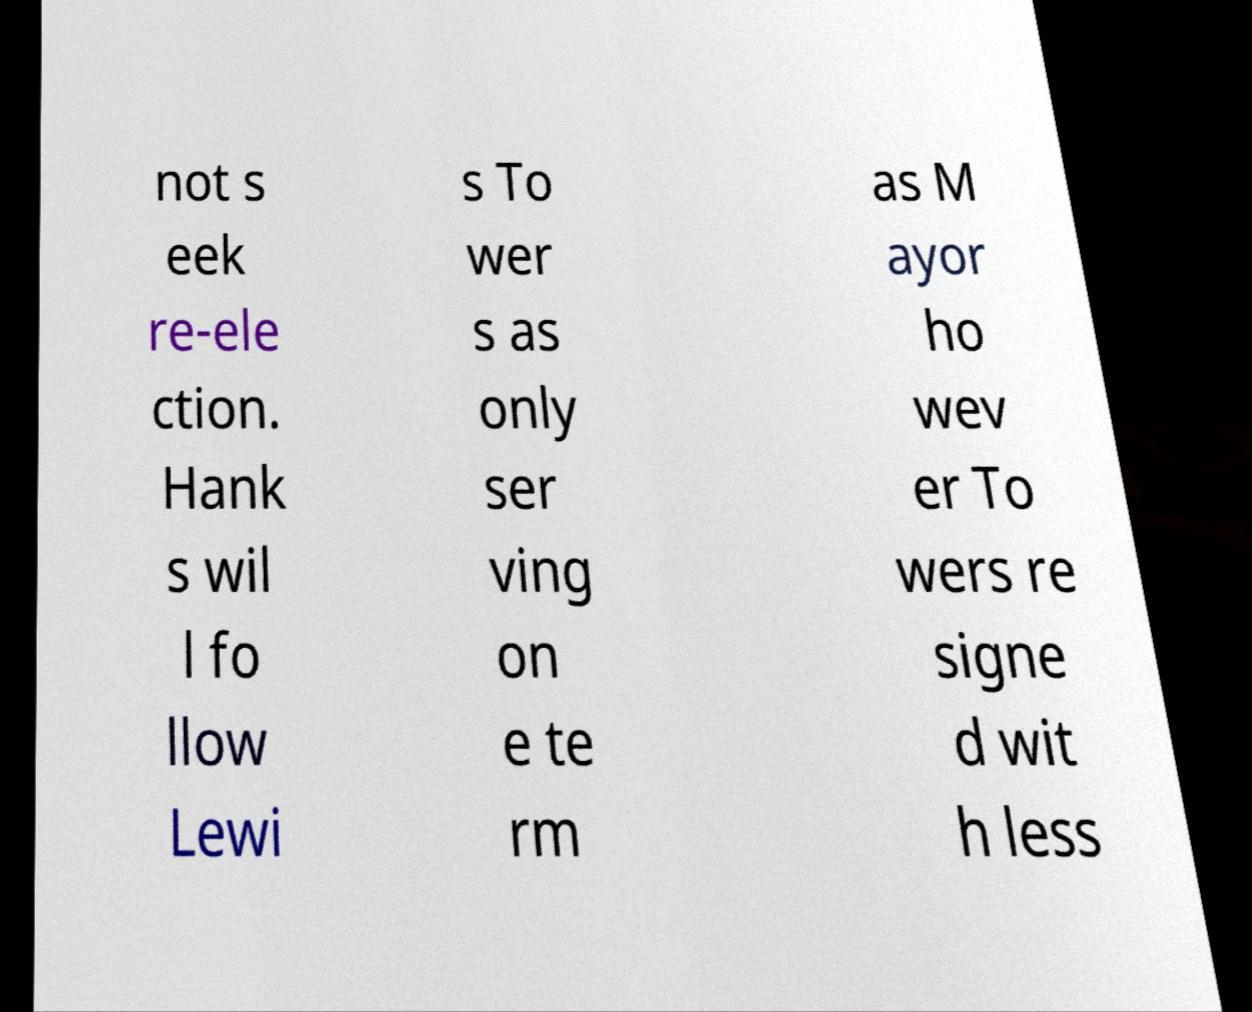Could you assist in decoding the text presented in this image and type it out clearly? not s eek re-ele ction. Hank s wil l fo llow Lewi s To wer s as only ser ving on e te rm as M ayor ho wev er To wers re signe d wit h less 